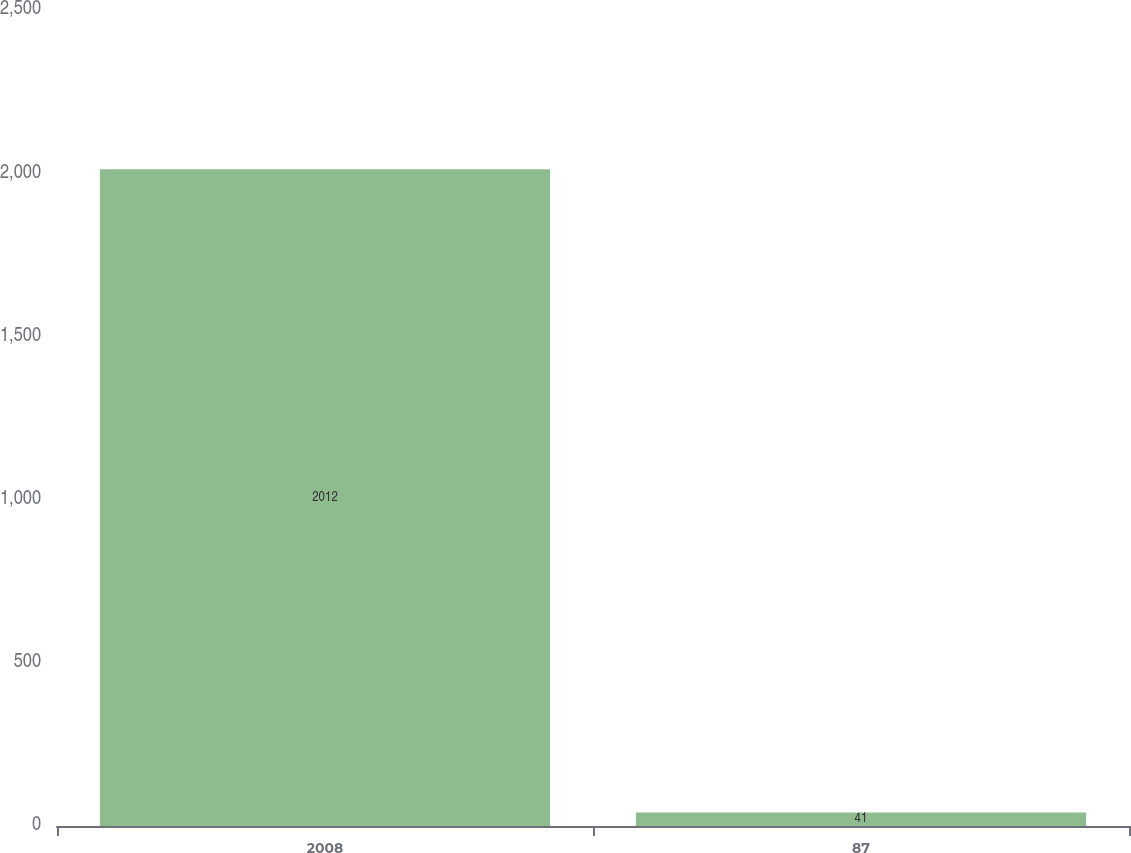<chart> <loc_0><loc_0><loc_500><loc_500><bar_chart><fcel>2008<fcel>87<nl><fcel>2012<fcel>41<nl></chart> 